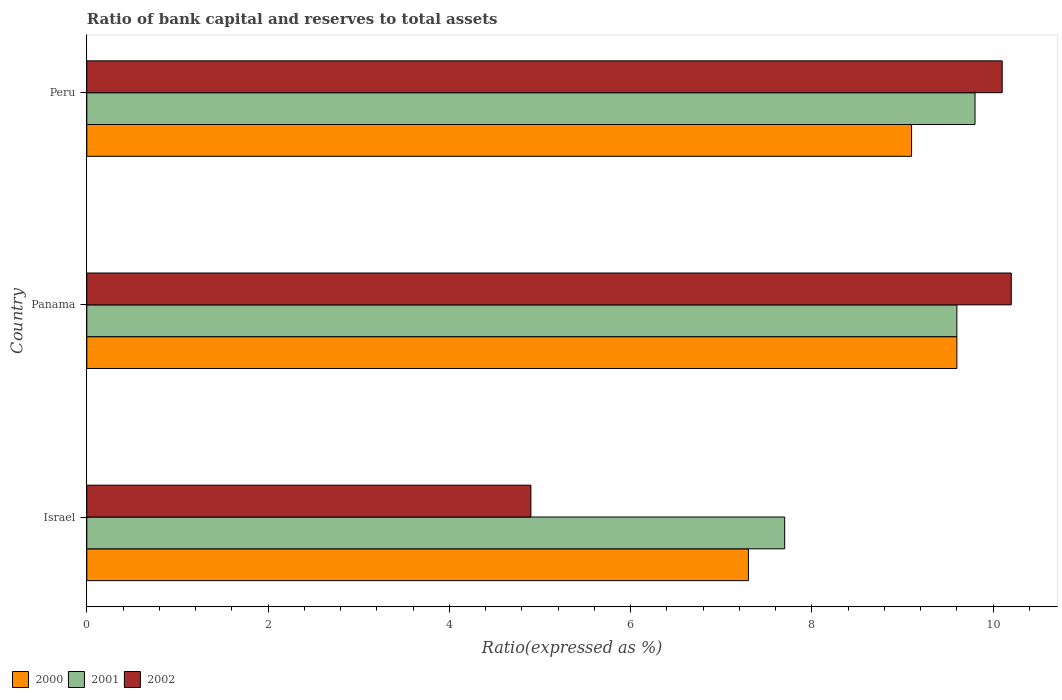How many different coloured bars are there?
Keep it short and to the point. 3. How many bars are there on the 3rd tick from the top?
Your response must be concise. 3. How many bars are there on the 1st tick from the bottom?
Keep it short and to the point. 3. What is the label of the 2nd group of bars from the top?
Provide a short and direct response. Panama. In how many cases, is the number of bars for a given country not equal to the number of legend labels?
Your response must be concise. 0. What is the ratio of bank capital and reserves to total assets in 2001 in Panama?
Provide a succinct answer. 9.6. Across all countries, what is the maximum ratio of bank capital and reserves to total assets in 2001?
Your answer should be very brief. 9.8. Across all countries, what is the minimum ratio of bank capital and reserves to total assets in 2000?
Your answer should be compact. 7.3. In which country was the ratio of bank capital and reserves to total assets in 2000 maximum?
Your answer should be very brief. Panama. In which country was the ratio of bank capital and reserves to total assets in 2000 minimum?
Provide a succinct answer. Israel. What is the total ratio of bank capital and reserves to total assets in 2000 in the graph?
Your answer should be compact. 26. What is the difference between the ratio of bank capital and reserves to total assets in 2001 in Panama and that in Peru?
Offer a terse response. -0.2. What is the difference between the ratio of bank capital and reserves to total assets in 2002 in Israel and the ratio of bank capital and reserves to total assets in 2000 in Panama?
Your answer should be very brief. -4.7. What is the difference between the ratio of bank capital and reserves to total assets in 2002 and ratio of bank capital and reserves to total assets in 2000 in Peru?
Offer a terse response. 1. In how many countries, is the ratio of bank capital and reserves to total assets in 2000 greater than 1.6 %?
Make the answer very short. 3. What is the ratio of the ratio of bank capital and reserves to total assets in 2001 in Israel to that in Panama?
Make the answer very short. 0.8. Is the ratio of bank capital and reserves to total assets in 2002 in Panama less than that in Peru?
Give a very brief answer. No. How many countries are there in the graph?
Offer a terse response. 3. Are the values on the major ticks of X-axis written in scientific E-notation?
Provide a succinct answer. No. Does the graph contain any zero values?
Keep it short and to the point. No. Does the graph contain grids?
Offer a very short reply. No. Where does the legend appear in the graph?
Make the answer very short. Bottom left. How many legend labels are there?
Give a very brief answer. 3. What is the title of the graph?
Give a very brief answer. Ratio of bank capital and reserves to total assets. Does "1994" appear as one of the legend labels in the graph?
Ensure brevity in your answer.  No. What is the label or title of the X-axis?
Your answer should be compact. Ratio(expressed as %). What is the Ratio(expressed as %) in 2000 in Israel?
Provide a succinct answer. 7.3. What is the Ratio(expressed as %) of 2001 in Israel?
Give a very brief answer. 7.7. What is the Ratio(expressed as %) of 2002 in Israel?
Provide a succinct answer. 4.9. What is the Ratio(expressed as %) of 2000 in Panama?
Your response must be concise. 9.6. What is the Ratio(expressed as %) in 2001 in Panama?
Give a very brief answer. 9.6. What is the Ratio(expressed as %) in 2002 in Panama?
Your answer should be very brief. 10.2. What is the Ratio(expressed as %) of 2000 in Peru?
Your answer should be compact. 9.1. What is the Ratio(expressed as %) in 2001 in Peru?
Ensure brevity in your answer.  9.8. Across all countries, what is the maximum Ratio(expressed as %) in 2002?
Offer a very short reply. 10.2. Across all countries, what is the minimum Ratio(expressed as %) in 2001?
Ensure brevity in your answer.  7.7. Across all countries, what is the minimum Ratio(expressed as %) of 2002?
Your answer should be compact. 4.9. What is the total Ratio(expressed as %) of 2001 in the graph?
Offer a very short reply. 27.1. What is the total Ratio(expressed as %) in 2002 in the graph?
Provide a succinct answer. 25.2. What is the difference between the Ratio(expressed as %) in 2000 in Israel and that in Panama?
Offer a terse response. -2.3. What is the difference between the Ratio(expressed as %) in 2002 in Israel and that in Panama?
Offer a terse response. -5.3. What is the difference between the Ratio(expressed as %) in 2000 in Israel and that in Peru?
Give a very brief answer. -1.8. What is the difference between the Ratio(expressed as %) in 2001 in Israel and that in Peru?
Give a very brief answer. -2.1. What is the difference between the Ratio(expressed as %) in 2002 in Israel and that in Peru?
Make the answer very short. -5.2. What is the difference between the Ratio(expressed as %) in 2000 in Panama and that in Peru?
Your response must be concise. 0.5. What is the difference between the Ratio(expressed as %) of 2002 in Panama and that in Peru?
Provide a short and direct response. 0.1. What is the difference between the Ratio(expressed as %) of 2000 in Israel and the Ratio(expressed as %) of 2001 in Panama?
Ensure brevity in your answer.  -2.3. What is the difference between the Ratio(expressed as %) in 2000 in Israel and the Ratio(expressed as %) in 2002 in Panama?
Keep it short and to the point. -2.9. What is the difference between the Ratio(expressed as %) of 2001 in Israel and the Ratio(expressed as %) of 2002 in Panama?
Offer a very short reply. -2.5. What is the difference between the Ratio(expressed as %) in 2000 in Israel and the Ratio(expressed as %) in 2002 in Peru?
Keep it short and to the point. -2.8. What is the difference between the Ratio(expressed as %) in 2000 in Panama and the Ratio(expressed as %) in 2001 in Peru?
Ensure brevity in your answer.  -0.2. What is the difference between the Ratio(expressed as %) of 2000 in Panama and the Ratio(expressed as %) of 2002 in Peru?
Keep it short and to the point. -0.5. What is the difference between the Ratio(expressed as %) of 2001 in Panama and the Ratio(expressed as %) of 2002 in Peru?
Offer a terse response. -0.5. What is the average Ratio(expressed as %) of 2000 per country?
Your response must be concise. 8.67. What is the average Ratio(expressed as %) of 2001 per country?
Make the answer very short. 9.03. What is the difference between the Ratio(expressed as %) of 2000 and Ratio(expressed as %) of 2001 in Israel?
Your response must be concise. -0.4. What is the difference between the Ratio(expressed as %) in 2001 and Ratio(expressed as %) in 2002 in Israel?
Your answer should be compact. 2.8. What is the difference between the Ratio(expressed as %) of 2001 and Ratio(expressed as %) of 2002 in Panama?
Give a very brief answer. -0.6. What is the difference between the Ratio(expressed as %) in 2001 and Ratio(expressed as %) in 2002 in Peru?
Give a very brief answer. -0.3. What is the ratio of the Ratio(expressed as %) of 2000 in Israel to that in Panama?
Offer a very short reply. 0.76. What is the ratio of the Ratio(expressed as %) in 2001 in Israel to that in Panama?
Offer a terse response. 0.8. What is the ratio of the Ratio(expressed as %) of 2002 in Israel to that in Panama?
Your answer should be compact. 0.48. What is the ratio of the Ratio(expressed as %) of 2000 in Israel to that in Peru?
Give a very brief answer. 0.8. What is the ratio of the Ratio(expressed as %) of 2001 in Israel to that in Peru?
Make the answer very short. 0.79. What is the ratio of the Ratio(expressed as %) in 2002 in Israel to that in Peru?
Give a very brief answer. 0.49. What is the ratio of the Ratio(expressed as %) in 2000 in Panama to that in Peru?
Offer a terse response. 1.05. What is the ratio of the Ratio(expressed as %) of 2001 in Panama to that in Peru?
Provide a short and direct response. 0.98. What is the ratio of the Ratio(expressed as %) of 2002 in Panama to that in Peru?
Make the answer very short. 1.01. What is the difference between the highest and the second highest Ratio(expressed as %) in 2001?
Provide a short and direct response. 0.2. What is the difference between the highest and the second highest Ratio(expressed as %) of 2002?
Ensure brevity in your answer.  0.1. What is the difference between the highest and the lowest Ratio(expressed as %) of 2002?
Keep it short and to the point. 5.3. 